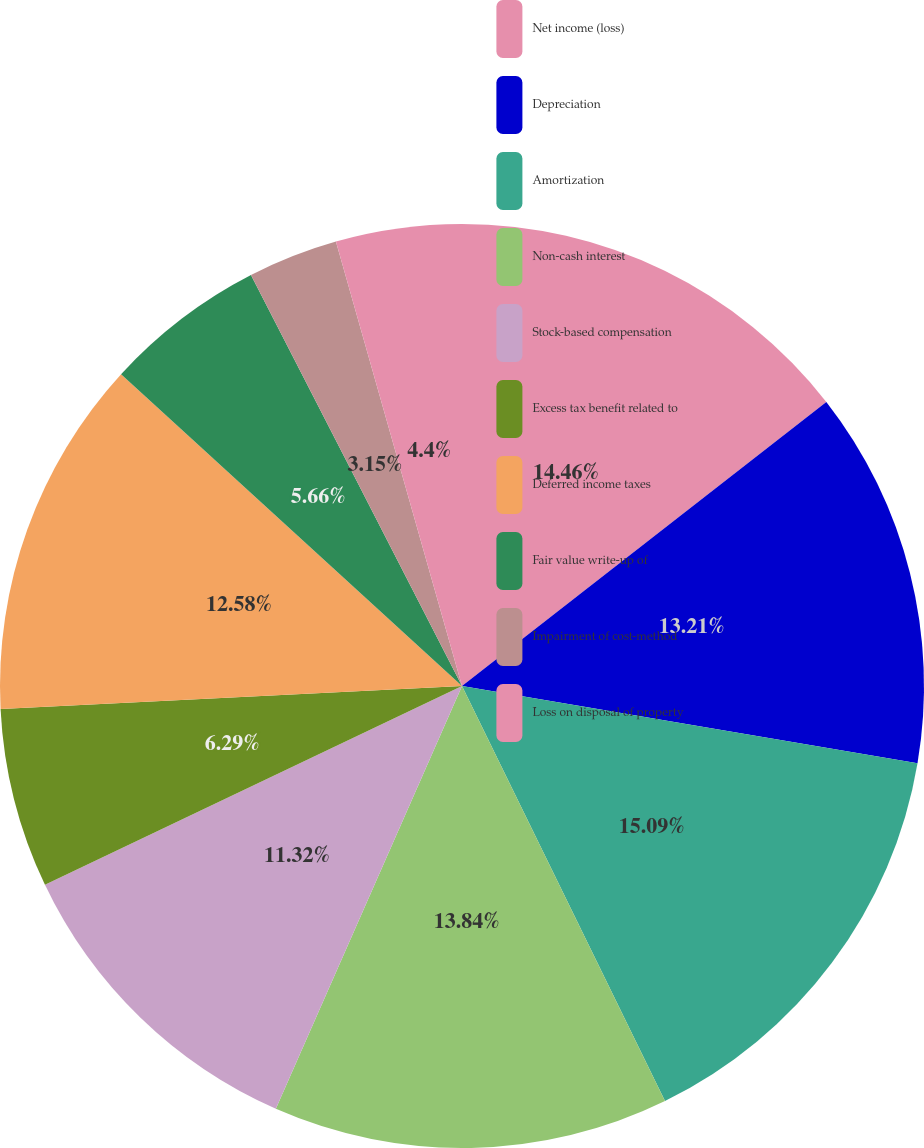<chart> <loc_0><loc_0><loc_500><loc_500><pie_chart><fcel>Net income (loss)<fcel>Depreciation<fcel>Amortization<fcel>Non-cash interest<fcel>Stock-based compensation<fcel>Excess tax benefit related to<fcel>Deferred income taxes<fcel>Fair value write-up of<fcel>Impairment of cost-method<fcel>Loss on disposal of property<nl><fcel>14.46%<fcel>13.21%<fcel>15.09%<fcel>13.84%<fcel>11.32%<fcel>6.29%<fcel>12.58%<fcel>5.66%<fcel>3.15%<fcel>4.4%<nl></chart> 